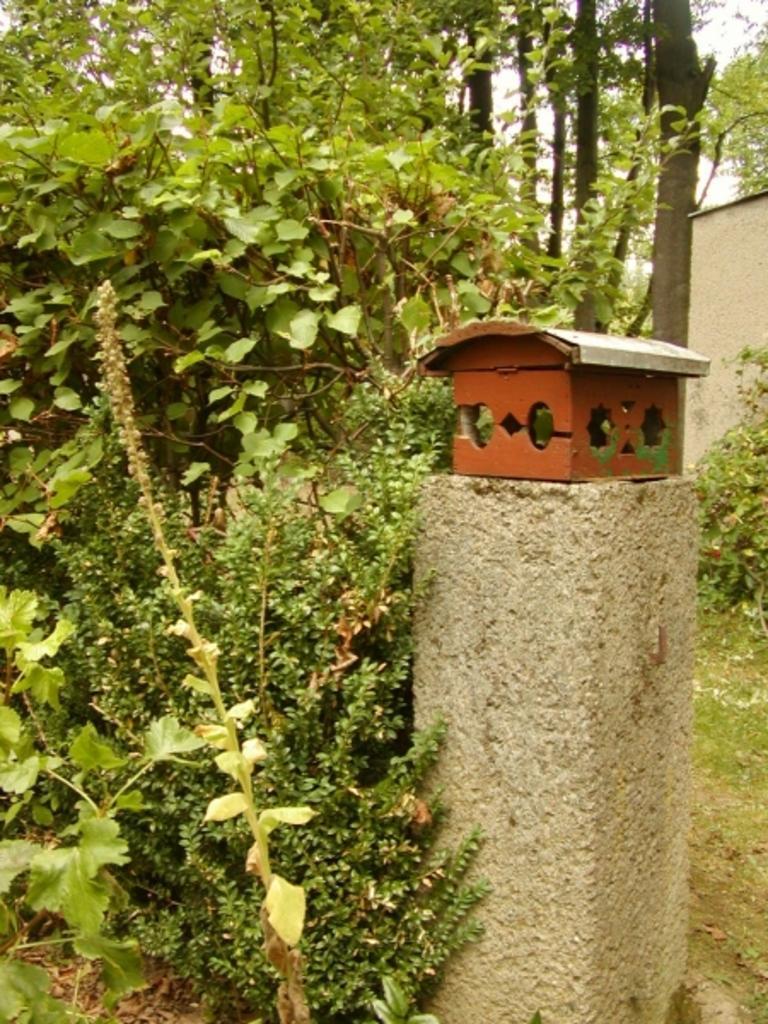Can you describe this image briefly? We can see box on the surface, plants and grass. In the background we can see trees, wall and sky. 